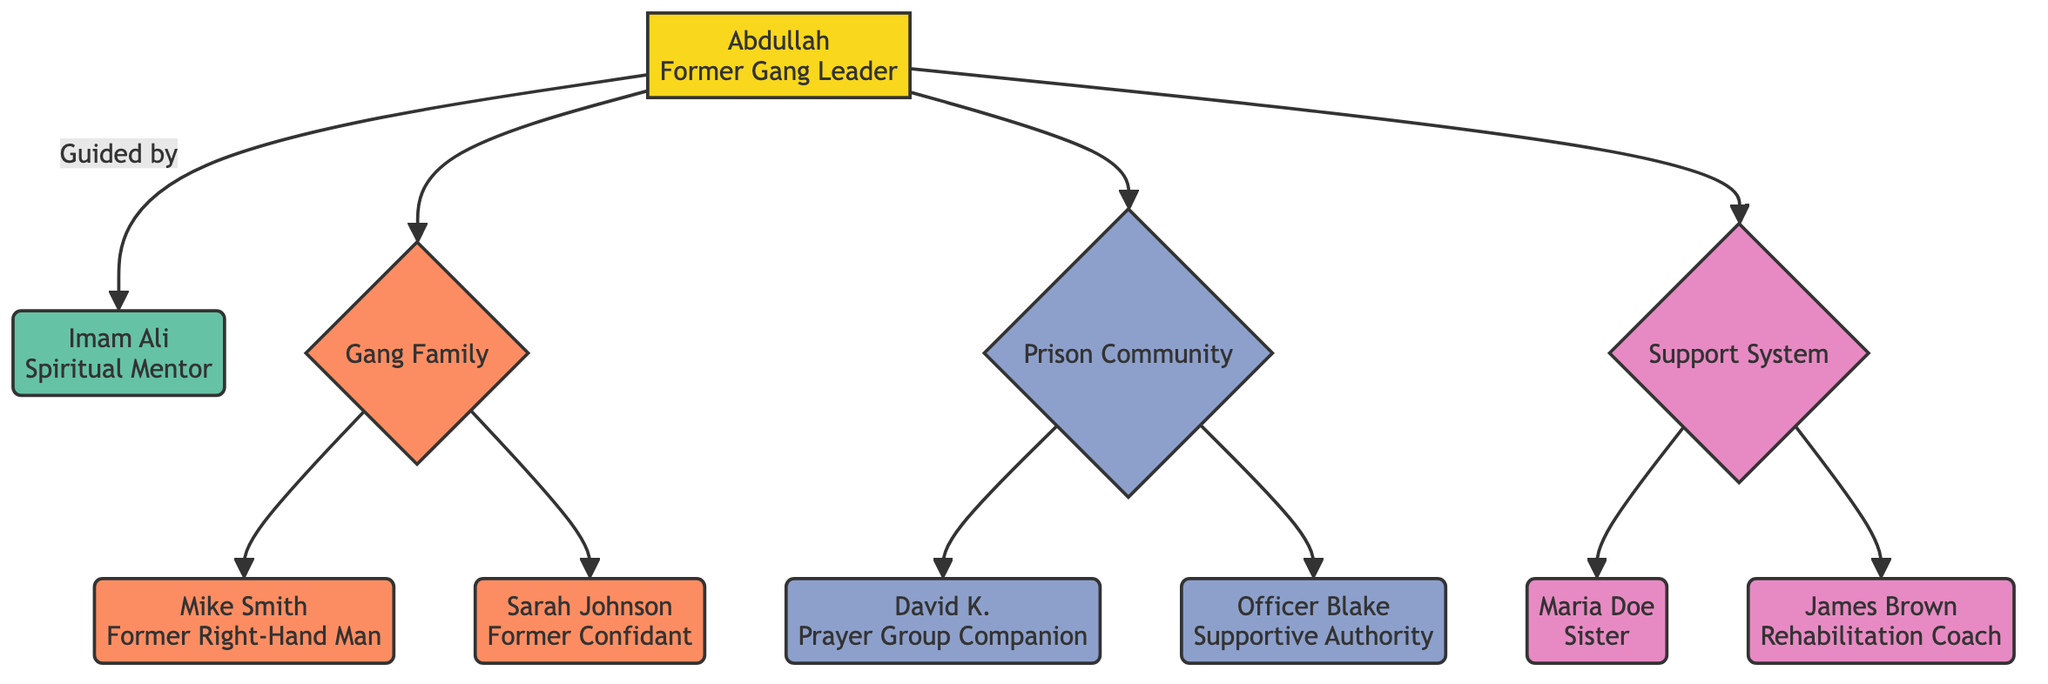What is the former name of the individual? The individual is described in the diagram with both a former and new name. According to the attributes for the "Individual" node, the former name is "John Doe."
Answer: John Doe How many members are in the Gang Family? The "Gang Family" node contains a list of members, which are "Mike Smith" and "Sarah Johnson." Counting these members results in a total of 2.
Answer: 2 Who is the Spiritual Mentor of the individual? The diagram explicitly states that the individual, Abdullah, is guided by the "Spiritual Mentor" node. The attributes for this node identify the mentor as "Imam Ali."
Answer: Imam Ali What role did Abdullah have in the gang? The diagram indicates Abdullah's role in the "Individual" node's attributes, where he is noted as a "Former Gang Leader."
Answer: Former Gang Leader Which relationship does David K. have to Abdullah? Looking at the "Prison Community" node, David K. is connected to Abdullah, described as his "Prayer Group Companion," indicating a supportive relationship.
Answer: Prayer Group Companion What is the age of Imam Ali? The mentor node provides the age of Imam Ali as part of its attributes, which states he is 50 years old.
Answer: 50 What role does Maria Doe play in Abdullah's support system? Within the "Support System" node, Maria Doe's role is defined as "Family Member," and her relationship to Abdullah is that of "Sister."
Answer: Sister Which individual has a role of "Supportive Authority"? Within the "Prison Community" node, the individual specifically identified with the role of "Supportive Authority" is "Officer Blake."
Answer: Officer Blake How is Mike Smith related to Abdullah? By checking the "Gang Family" node, Mike Smith is designated as a "Former Right-Hand Man" to Abdullah, establishing a direct relationship based on former association.
Answer: Former Right-Hand Man 